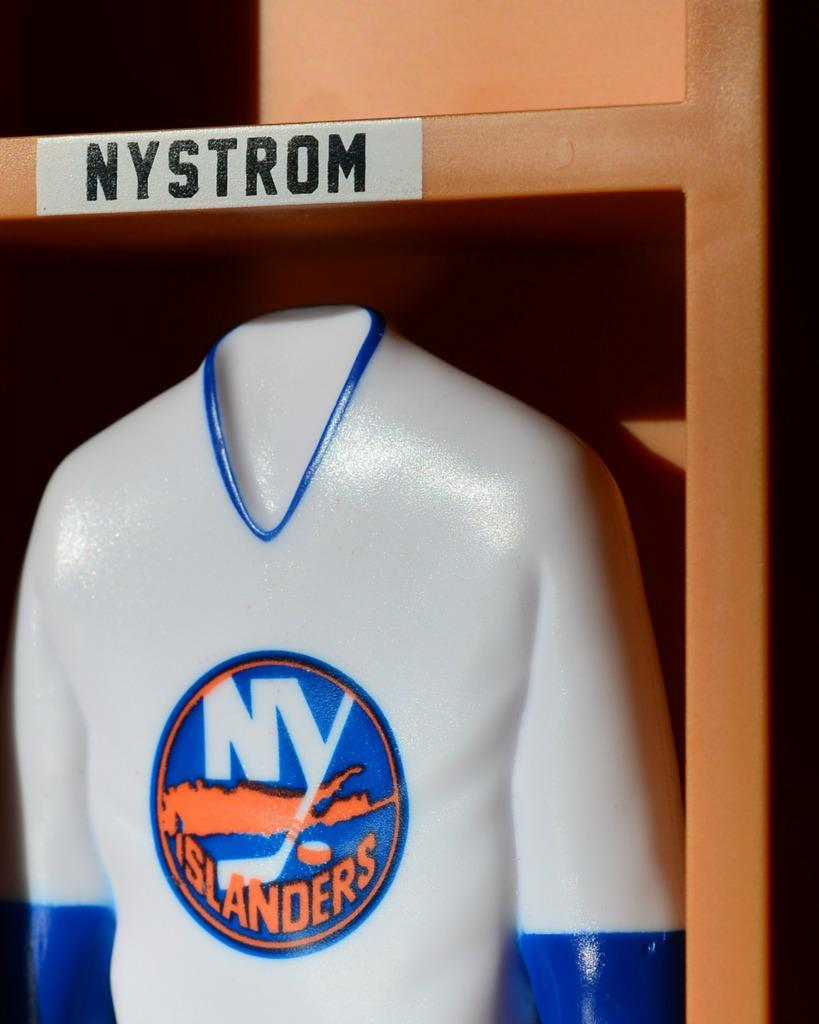<image>
Offer a succinct explanation of the picture presented. A mold of a human with a NY Islanders jersey on 